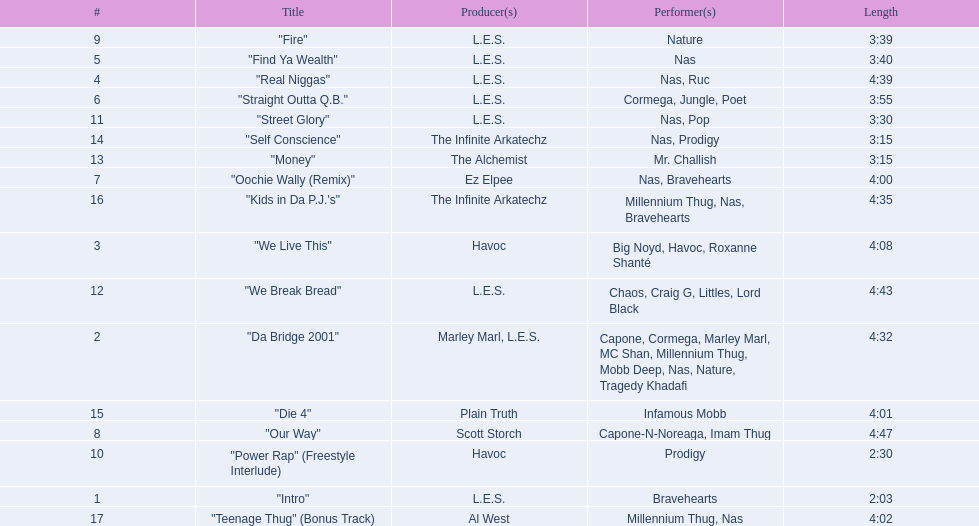How long is each song? 2:03, 4:32, 4:08, 4:39, 3:40, 3:55, 4:00, 4:47, 3:39, 2:30, 3:30, 4:43, 3:15, 3:15, 4:01, 4:35, 4:02. What length is the longest? 4:47. 